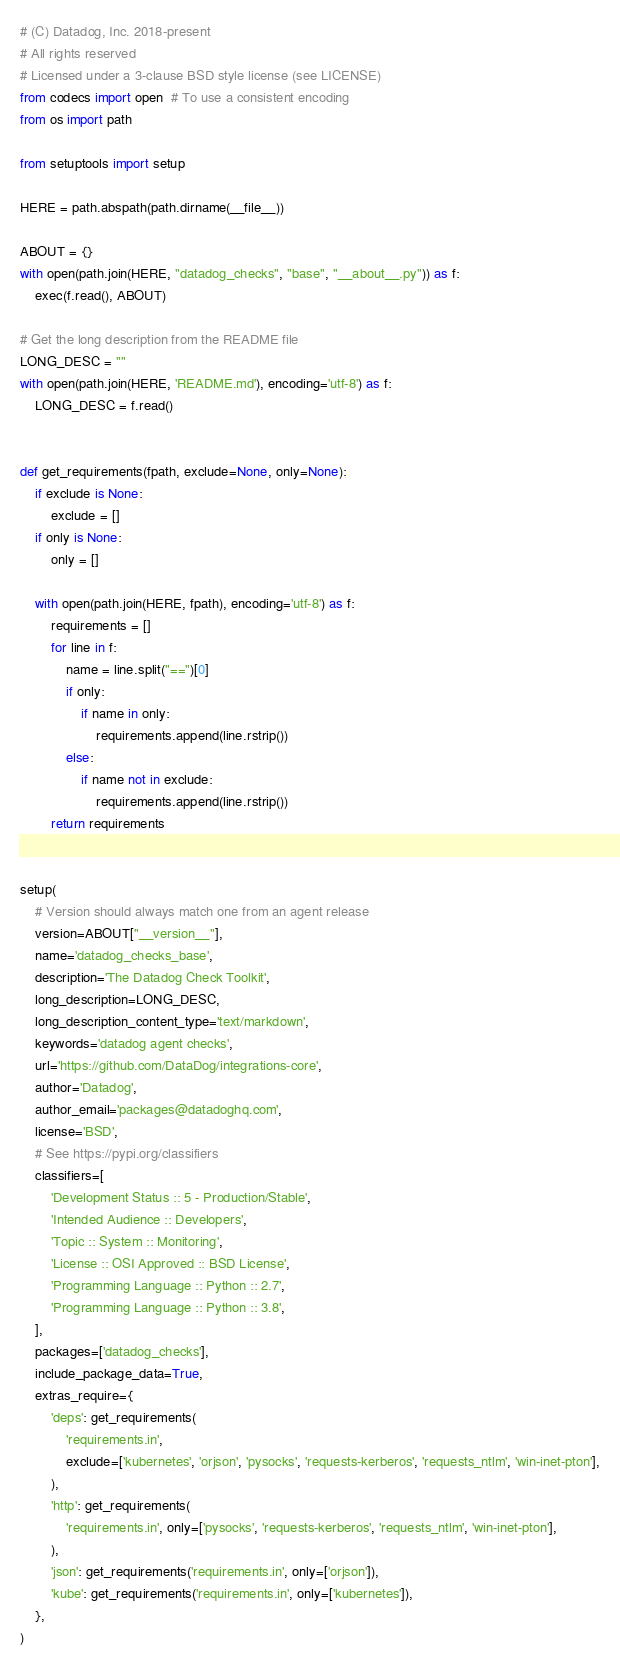<code> <loc_0><loc_0><loc_500><loc_500><_Python_># (C) Datadog, Inc. 2018-present
# All rights reserved
# Licensed under a 3-clause BSD style license (see LICENSE)
from codecs import open  # To use a consistent encoding
from os import path

from setuptools import setup

HERE = path.abspath(path.dirname(__file__))

ABOUT = {}
with open(path.join(HERE, "datadog_checks", "base", "__about__.py")) as f:
    exec(f.read(), ABOUT)

# Get the long description from the README file
LONG_DESC = ""
with open(path.join(HERE, 'README.md'), encoding='utf-8') as f:
    LONG_DESC = f.read()


def get_requirements(fpath, exclude=None, only=None):
    if exclude is None:
        exclude = []
    if only is None:
        only = []

    with open(path.join(HERE, fpath), encoding='utf-8') as f:
        requirements = []
        for line in f:
            name = line.split("==")[0]
            if only:
                if name in only:
                    requirements.append(line.rstrip())
            else:
                if name not in exclude:
                    requirements.append(line.rstrip())
        return requirements


setup(
    # Version should always match one from an agent release
    version=ABOUT["__version__"],
    name='datadog_checks_base',
    description='The Datadog Check Toolkit',
    long_description=LONG_DESC,
    long_description_content_type='text/markdown',
    keywords='datadog agent checks',
    url='https://github.com/DataDog/integrations-core',
    author='Datadog',
    author_email='packages@datadoghq.com',
    license='BSD',
    # See https://pypi.org/classifiers
    classifiers=[
        'Development Status :: 5 - Production/Stable',
        'Intended Audience :: Developers',
        'Topic :: System :: Monitoring',
        'License :: OSI Approved :: BSD License',
        'Programming Language :: Python :: 2.7',
        'Programming Language :: Python :: 3.8',
    ],
    packages=['datadog_checks'],
    include_package_data=True,
    extras_require={
        'deps': get_requirements(
            'requirements.in',
            exclude=['kubernetes', 'orjson', 'pysocks', 'requests-kerberos', 'requests_ntlm', 'win-inet-pton'],
        ),
        'http': get_requirements(
            'requirements.in', only=['pysocks', 'requests-kerberos', 'requests_ntlm', 'win-inet-pton'],
        ),
        'json': get_requirements('requirements.in', only=['orjson']),
        'kube': get_requirements('requirements.in', only=['kubernetes']),
    },
)
</code> 